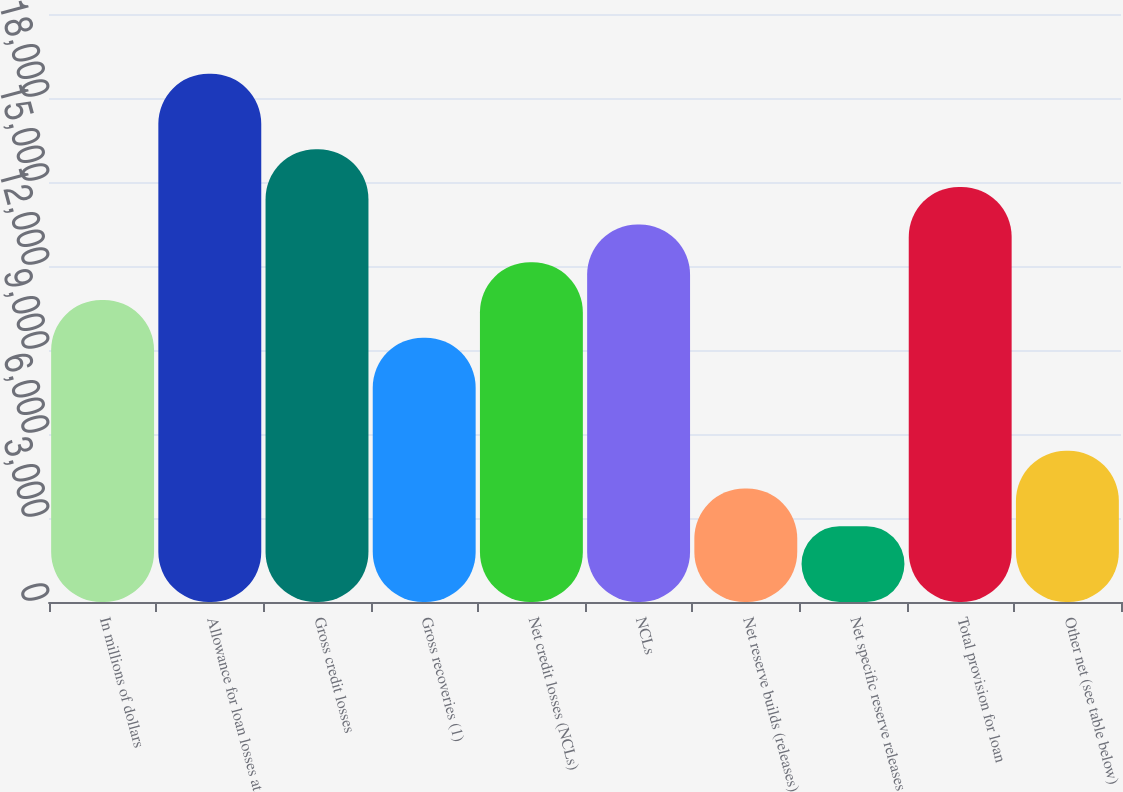<chart> <loc_0><loc_0><loc_500><loc_500><bar_chart><fcel>In millions of dollars<fcel>Allowance for loan losses at<fcel>Gross credit losses<fcel>Gross recoveries (1)<fcel>Net credit losses (NCLs)<fcel>NCLs<fcel>Net reserve builds (releases)<fcel>Net specific reserve releases<fcel>Total provision for loan<fcel>Other net (see table below)<nl><fcel>10785<fcel>18864<fcel>16171<fcel>9438.5<fcel>12131.5<fcel>13478<fcel>4052.5<fcel>2706<fcel>14824.5<fcel>5399<nl></chart> 